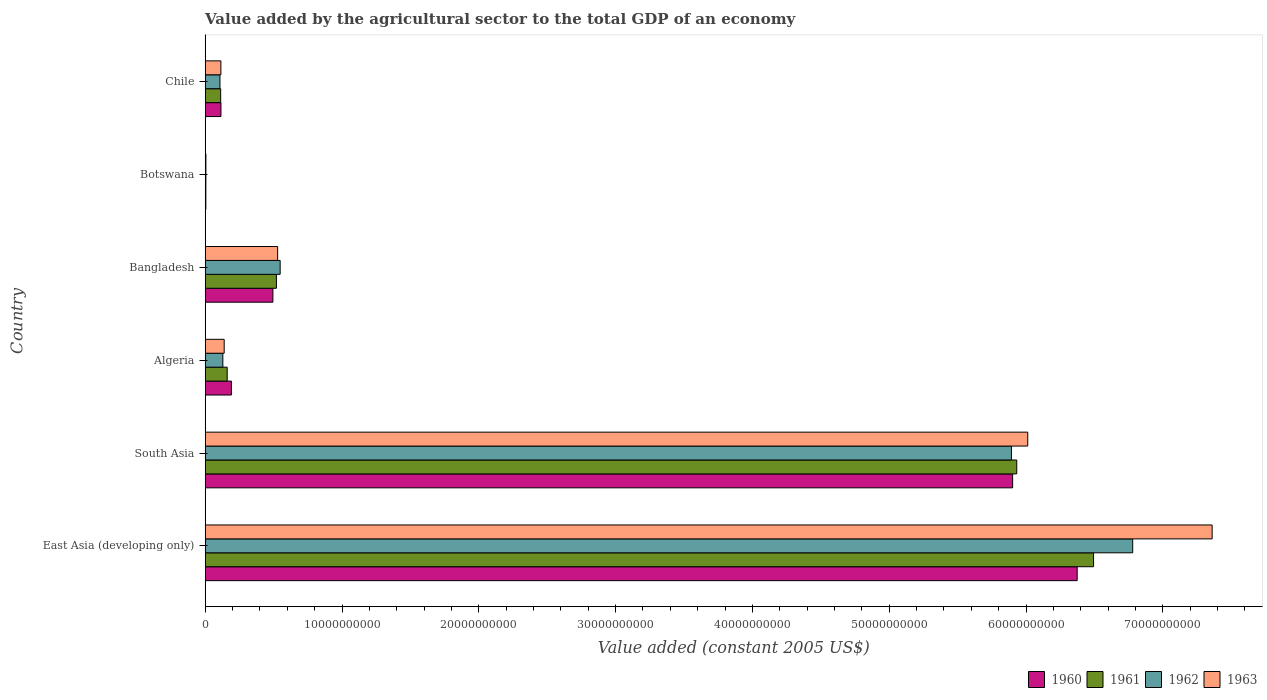How many different coloured bars are there?
Your answer should be very brief. 4. Are the number of bars per tick equal to the number of legend labels?
Offer a very short reply. Yes. How many bars are there on the 6th tick from the top?
Make the answer very short. 4. How many bars are there on the 1st tick from the bottom?
Keep it short and to the point. 4. What is the value added by the agricultural sector in 1962 in Algeria?
Your answer should be compact. 1.29e+09. Across all countries, what is the maximum value added by the agricultural sector in 1963?
Your answer should be very brief. 7.36e+1. Across all countries, what is the minimum value added by the agricultural sector in 1961?
Offer a very short reply. 4.86e+07. In which country was the value added by the agricultural sector in 1960 maximum?
Offer a terse response. East Asia (developing only). In which country was the value added by the agricultural sector in 1963 minimum?
Your answer should be very brief. Botswana. What is the total value added by the agricultural sector in 1961 in the graph?
Your response must be concise. 1.32e+11. What is the difference between the value added by the agricultural sector in 1963 in Chile and that in East Asia (developing only)?
Your answer should be compact. -7.25e+1. What is the difference between the value added by the agricultural sector in 1961 in South Asia and the value added by the agricultural sector in 1962 in Bangladesh?
Make the answer very short. 5.38e+1. What is the average value added by the agricultural sector in 1963 per country?
Ensure brevity in your answer.  2.36e+1. What is the difference between the value added by the agricultural sector in 1960 and value added by the agricultural sector in 1963 in Botswana?
Make the answer very short. -4.67e+06. What is the ratio of the value added by the agricultural sector in 1960 in Bangladesh to that in Chile?
Ensure brevity in your answer.  4.3. What is the difference between the highest and the second highest value added by the agricultural sector in 1960?
Your answer should be compact. 4.72e+09. What is the difference between the highest and the lowest value added by the agricultural sector in 1962?
Make the answer very short. 6.77e+1. In how many countries, is the value added by the agricultural sector in 1963 greater than the average value added by the agricultural sector in 1963 taken over all countries?
Provide a short and direct response. 2. Is the sum of the value added by the agricultural sector in 1961 in Algeria and Bangladesh greater than the maximum value added by the agricultural sector in 1962 across all countries?
Make the answer very short. No. Is it the case that in every country, the sum of the value added by the agricultural sector in 1961 and value added by the agricultural sector in 1960 is greater than the sum of value added by the agricultural sector in 1963 and value added by the agricultural sector in 1962?
Provide a succinct answer. No. What does the 1st bar from the bottom in Botswana represents?
Ensure brevity in your answer.  1960. Is it the case that in every country, the sum of the value added by the agricultural sector in 1960 and value added by the agricultural sector in 1961 is greater than the value added by the agricultural sector in 1963?
Provide a succinct answer. Yes. How many legend labels are there?
Make the answer very short. 4. What is the title of the graph?
Keep it short and to the point. Value added by the agricultural sector to the total GDP of an economy. Does "1961" appear as one of the legend labels in the graph?
Ensure brevity in your answer.  Yes. What is the label or title of the X-axis?
Give a very brief answer. Value added (constant 2005 US$). What is the Value added (constant 2005 US$) of 1960 in East Asia (developing only)?
Offer a very short reply. 6.37e+1. What is the Value added (constant 2005 US$) in 1961 in East Asia (developing only)?
Make the answer very short. 6.49e+1. What is the Value added (constant 2005 US$) of 1962 in East Asia (developing only)?
Provide a succinct answer. 6.78e+1. What is the Value added (constant 2005 US$) of 1963 in East Asia (developing only)?
Your answer should be very brief. 7.36e+1. What is the Value added (constant 2005 US$) of 1960 in South Asia?
Offer a very short reply. 5.90e+1. What is the Value added (constant 2005 US$) in 1961 in South Asia?
Your answer should be very brief. 5.93e+1. What is the Value added (constant 2005 US$) of 1962 in South Asia?
Your response must be concise. 5.89e+1. What is the Value added (constant 2005 US$) of 1963 in South Asia?
Ensure brevity in your answer.  6.01e+1. What is the Value added (constant 2005 US$) in 1960 in Algeria?
Your answer should be very brief. 1.92e+09. What is the Value added (constant 2005 US$) of 1961 in Algeria?
Make the answer very short. 1.61e+09. What is the Value added (constant 2005 US$) in 1962 in Algeria?
Make the answer very short. 1.29e+09. What is the Value added (constant 2005 US$) of 1963 in Algeria?
Provide a succinct answer. 1.39e+09. What is the Value added (constant 2005 US$) in 1960 in Bangladesh?
Provide a succinct answer. 4.95e+09. What is the Value added (constant 2005 US$) of 1961 in Bangladesh?
Your answer should be compact. 5.21e+09. What is the Value added (constant 2005 US$) of 1962 in Bangladesh?
Provide a succinct answer. 5.48e+09. What is the Value added (constant 2005 US$) in 1963 in Bangladesh?
Your response must be concise. 5.30e+09. What is the Value added (constant 2005 US$) of 1960 in Botswana?
Provide a short and direct response. 4.74e+07. What is the Value added (constant 2005 US$) of 1961 in Botswana?
Provide a short and direct response. 4.86e+07. What is the Value added (constant 2005 US$) of 1962 in Botswana?
Your answer should be compact. 5.04e+07. What is the Value added (constant 2005 US$) of 1963 in Botswana?
Offer a terse response. 5.21e+07. What is the Value added (constant 2005 US$) of 1960 in Chile?
Give a very brief answer. 1.15e+09. What is the Value added (constant 2005 US$) of 1961 in Chile?
Give a very brief answer. 1.13e+09. What is the Value added (constant 2005 US$) of 1962 in Chile?
Offer a terse response. 1.08e+09. What is the Value added (constant 2005 US$) in 1963 in Chile?
Make the answer very short. 1.15e+09. Across all countries, what is the maximum Value added (constant 2005 US$) of 1960?
Ensure brevity in your answer.  6.37e+1. Across all countries, what is the maximum Value added (constant 2005 US$) of 1961?
Provide a succinct answer. 6.49e+1. Across all countries, what is the maximum Value added (constant 2005 US$) of 1962?
Your response must be concise. 6.78e+1. Across all countries, what is the maximum Value added (constant 2005 US$) in 1963?
Offer a terse response. 7.36e+1. Across all countries, what is the minimum Value added (constant 2005 US$) in 1960?
Your answer should be very brief. 4.74e+07. Across all countries, what is the minimum Value added (constant 2005 US$) in 1961?
Keep it short and to the point. 4.86e+07. Across all countries, what is the minimum Value added (constant 2005 US$) of 1962?
Your response must be concise. 5.04e+07. Across all countries, what is the minimum Value added (constant 2005 US$) of 1963?
Your response must be concise. 5.21e+07. What is the total Value added (constant 2005 US$) of 1960 in the graph?
Make the answer very short. 1.31e+11. What is the total Value added (constant 2005 US$) in 1961 in the graph?
Make the answer very short. 1.32e+11. What is the total Value added (constant 2005 US$) of 1962 in the graph?
Ensure brevity in your answer.  1.35e+11. What is the total Value added (constant 2005 US$) in 1963 in the graph?
Your answer should be compact. 1.42e+11. What is the difference between the Value added (constant 2005 US$) in 1960 in East Asia (developing only) and that in South Asia?
Give a very brief answer. 4.72e+09. What is the difference between the Value added (constant 2005 US$) of 1961 in East Asia (developing only) and that in South Asia?
Give a very brief answer. 5.62e+09. What is the difference between the Value added (constant 2005 US$) in 1962 in East Asia (developing only) and that in South Asia?
Your response must be concise. 8.86e+09. What is the difference between the Value added (constant 2005 US$) of 1963 in East Asia (developing only) and that in South Asia?
Provide a short and direct response. 1.35e+1. What is the difference between the Value added (constant 2005 US$) of 1960 in East Asia (developing only) and that in Algeria?
Offer a terse response. 6.18e+1. What is the difference between the Value added (constant 2005 US$) of 1961 in East Asia (developing only) and that in Algeria?
Give a very brief answer. 6.33e+1. What is the difference between the Value added (constant 2005 US$) of 1962 in East Asia (developing only) and that in Algeria?
Give a very brief answer. 6.65e+1. What is the difference between the Value added (constant 2005 US$) in 1963 in East Asia (developing only) and that in Algeria?
Make the answer very short. 7.22e+1. What is the difference between the Value added (constant 2005 US$) of 1960 in East Asia (developing only) and that in Bangladesh?
Your answer should be compact. 5.88e+1. What is the difference between the Value added (constant 2005 US$) in 1961 in East Asia (developing only) and that in Bangladesh?
Your answer should be very brief. 5.97e+1. What is the difference between the Value added (constant 2005 US$) in 1962 in East Asia (developing only) and that in Bangladesh?
Provide a short and direct response. 6.23e+1. What is the difference between the Value added (constant 2005 US$) of 1963 in East Asia (developing only) and that in Bangladesh?
Your response must be concise. 6.83e+1. What is the difference between the Value added (constant 2005 US$) of 1960 in East Asia (developing only) and that in Botswana?
Provide a succinct answer. 6.37e+1. What is the difference between the Value added (constant 2005 US$) in 1961 in East Asia (developing only) and that in Botswana?
Make the answer very short. 6.49e+1. What is the difference between the Value added (constant 2005 US$) in 1962 in East Asia (developing only) and that in Botswana?
Your answer should be very brief. 6.77e+1. What is the difference between the Value added (constant 2005 US$) of 1963 in East Asia (developing only) and that in Botswana?
Give a very brief answer. 7.36e+1. What is the difference between the Value added (constant 2005 US$) in 1960 in East Asia (developing only) and that in Chile?
Your response must be concise. 6.26e+1. What is the difference between the Value added (constant 2005 US$) of 1961 in East Asia (developing only) and that in Chile?
Make the answer very short. 6.38e+1. What is the difference between the Value added (constant 2005 US$) in 1962 in East Asia (developing only) and that in Chile?
Give a very brief answer. 6.67e+1. What is the difference between the Value added (constant 2005 US$) of 1963 in East Asia (developing only) and that in Chile?
Ensure brevity in your answer.  7.25e+1. What is the difference between the Value added (constant 2005 US$) in 1960 in South Asia and that in Algeria?
Ensure brevity in your answer.  5.71e+1. What is the difference between the Value added (constant 2005 US$) in 1961 in South Asia and that in Algeria?
Offer a terse response. 5.77e+1. What is the difference between the Value added (constant 2005 US$) in 1962 in South Asia and that in Algeria?
Give a very brief answer. 5.76e+1. What is the difference between the Value added (constant 2005 US$) in 1963 in South Asia and that in Algeria?
Give a very brief answer. 5.87e+1. What is the difference between the Value added (constant 2005 US$) of 1960 in South Asia and that in Bangladesh?
Provide a succinct answer. 5.41e+1. What is the difference between the Value added (constant 2005 US$) in 1961 in South Asia and that in Bangladesh?
Your answer should be very brief. 5.41e+1. What is the difference between the Value added (constant 2005 US$) in 1962 in South Asia and that in Bangladesh?
Provide a succinct answer. 5.35e+1. What is the difference between the Value added (constant 2005 US$) in 1963 in South Asia and that in Bangladesh?
Make the answer very short. 5.48e+1. What is the difference between the Value added (constant 2005 US$) of 1960 in South Asia and that in Botswana?
Provide a short and direct response. 5.90e+1. What is the difference between the Value added (constant 2005 US$) in 1961 in South Asia and that in Botswana?
Your response must be concise. 5.93e+1. What is the difference between the Value added (constant 2005 US$) in 1962 in South Asia and that in Botswana?
Keep it short and to the point. 5.89e+1. What is the difference between the Value added (constant 2005 US$) in 1963 in South Asia and that in Botswana?
Keep it short and to the point. 6.01e+1. What is the difference between the Value added (constant 2005 US$) of 1960 in South Asia and that in Chile?
Provide a succinct answer. 5.79e+1. What is the difference between the Value added (constant 2005 US$) of 1961 in South Asia and that in Chile?
Keep it short and to the point. 5.82e+1. What is the difference between the Value added (constant 2005 US$) of 1962 in South Asia and that in Chile?
Keep it short and to the point. 5.79e+1. What is the difference between the Value added (constant 2005 US$) in 1963 in South Asia and that in Chile?
Give a very brief answer. 5.90e+1. What is the difference between the Value added (constant 2005 US$) of 1960 in Algeria and that in Bangladesh?
Give a very brief answer. -3.03e+09. What is the difference between the Value added (constant 2005 US$) of 1961 in Algeria and that in Bangladesh?
Your answer should be compact. -3.60e+09. What is the difference between the Value added (constant 2005 US$) in 1962 in Algeria and that in Bangladesh?
Keep it short and to the point. -4.19e+09. What is the difference between the Value added (constant 2005 US$) in 1963 in Algeria and that in Bangladesh?
Provide a succinct answer. -3.91e+09. What is the difference between the Value added (constant 2005 US$) of 1960 in Algeria and that in Botswana?
Ensure brevity in your answer.  1.87e+09. What is the difference between the Value added (constant 2005 US$) of 1961 in Algeria and that in Botswana?
Provide a succinct answer. 1.56e+09. What is the difference between the Value added (constant 2005 US$) in 1962 in Algeria and that in Botswana?
Offer a terse response. 1.24e+09. What is the difference between the Value added (constant 2005 US$) in 1963 in Algeria and that in Botswana?
Make the answer very short. 1.34e+09. What is the difference between the Value added (constant 2005 US$) in 1960 in Algeria and that in Chile?
Your response must be concise. 7.63e+08. What is the difference between the Value added (constant 2005 US$) in 1961 in Algeria and that in Chile?
Make the answer very short. 4.78e+08. What is the difference between the Value added (constant 2005 US$) of 1962 in Algeria and that in Chile?
Offer a very short reply. 2.11e+08. What is the difference between the Value added (constant 2005 US$) in 1963 in Algeria and that in Chile?
Offer a terse response. 2.42e+08. What is the difference between the Value added (constant 2005 US$) in 1960 in Bangladesh and that in Botswana?
Ensure brevity in your answer.  4.90e+09. What is the difference between the Value added (constant 2005 US$) of 1961 in Bangladesh and that in Botswana?
Provide a short and direct response. 5.16e+09. What is the difference between the Value added (constant 2005 US$) in 1962 in Bangladesh and that in Botswana?
Offer a terse response. 5.43e+09. What is the difference between the Value added (constant 2005 US$) in 1963 in Bangladesh and that in Botswana?
Offer a very short reply. 5.24e+09. What is the difference between the Value added (constant 2005 US$) in 1960 in Bangladesh and that in Chile?
Ensure brevity in your answer.  3.80e+09. What is the difference between the Value added (constant 2005 US$) in 1961 in Bangladesh and that in Chile?
Make the answer very short. 4.08e+09. What is the difference between the Value added (constant 2005 US$) of 1962 in Bangladesh and that in Chile?
Your response must be concise. 4.40e+09. What is the difference between the Value added (constant 2005 US$) in 1963 in Bangladesh and that in Chile?
Keep it short and to the point. 4.15e+09. What is the difference between the Value added (constant 2005 US$) in 1960 in Botswana and that in Chile?
Offer a very short reply. -1.10e+09. What is the difference between the Value added (constant 2005 US$) of 1961 in Botswana and that in Chile?
Provide a succinct answer. -1.08e+09. What is the difference between the Value added (constant 2005 US$) of 1962 in Botswana and that in Chile?
Your response must be concise. -1.03e+09. What is the difference between the Value added (constant 2005 US$) in 1963 in Botswana and that in Chile?
Offer a very short reply. -1.09e+09. What is the difference between the Value added (constant 2005 US$) in 1960 in East Asia (developing only) and the Value added (constant 2005 US$) in 1961 in South Asia?
Keep it short and to the point. 4.42e+09. What is the difference between the Value added (constant 2005 US$) in 1960 in East Asia (developing only) and the Value added (constant 2005 US$) in 1962 in South Asia?
Keep it short and to the point. 4.81e+09. What is the difference between the Value added (constant 2005 US$) in 1960 in East Asia (developing only) and the Value added (constant 2005 US$) in 1963 in South Asia?
Make the answer very short. 3.61e+09. What is the difference between the Value added (constant 2005 US$) in 1961 in East Asia (developing only) and the Value added (constant 2005 US$) in 1962 in South Asia?
Provide a short and direct response. 6.00e+09. What is the difference between the Value added (constant 2005 US$) of 1961 in East Asia (developing only) and the Value added (constant 2005 US$) of 1963 in South Asia?
Provide a short and direct response. 4.81e+09. What is the difference between the Value added (constant 2005 US$) of 1962 in East Asia (developing only) and the Value added (constant 2005 US$) of 1963 in South Asia?
Ensure brevity in your answer.  7.67e+09. What is the difference between the Value added (constant 2005 US$) of 1960 in East Asia (developing only) and the Value added (constant 2005 US$) of 1961 in Algeria?
Offer a very short reply. 6.21e+1. What is the difference between the Value added (constant 2005 US$) of 1960 in East Asia (developing only) and the Value added (constant 2005 US$) of 1962 in Algeria?
Your response must be concise. 6.24e+1. What is the difference between the Value added (constant 2005 US$) in 1960 in East Asia (developing only) and the Value added (constant 2005 US$) in 1963 in Algeria?
Offer a very short reply. 6.23e+1. What is the difference between the Value added (constant 2005 US$) in 1961 in East Asia (developing only) and the Value added (constant 2005 US$) in 1962 in Algeria?
Keep it short and to the point. 6.36e+1. What is the difference between the Value added (constant 2005 US$) in 1961 in East Asia (developing only) and the Value added (constant 2005 US$) in 1963 in Algeria?
Offer a very short reply. 6.35e+1. What is the difference between the Value added (constant 2005 US$) in 1962 in East Asia (developing only) and the Value added (constant 2005 US$) in 1963 in Algeria?
Your answer should be compact. 6.64e+1. What is the difference between the Value added (constant 2005 US$) in 1960 in East Asia (developing only) and the Value added (constant 2005 US$) in 1961 in Bangladesh?
Your answer should be compact. 5.85e+1. What is the difference between the Value added (constant 2005 US$) in 1960 in East Asia (developing only) and the Value added (constant 2005 US$) in 1962 in Bangladesh?
Keep it short and to the point. 5.83e+1. What is the difference between the Value added (constant 2005 US$) in 1960 in East Asia (developing only) and the Value added (constant 2005 US$) in 1963 in Bangladesh?
Provide a short and direct response. 5.84e+1. What is the difference between the Value added (constant 2005 US$) in 1961 in East Asia (developing only) and the Value added (constant 2005 US$) in 1962 in Bangladesh?
Make the answer very short. 5.95e+1. What is the difference between the Value added (constant 2005 US$) of 1961 in East Asia (developing only) and the Value added (constant 2005 US$) of 1963 in Bangladesh?
Offer a terse response. 5.96e+1. What is the difference between the Value added (constant 2005 US$) in 1962 in East Asia (developing only) and the Value added (constant 2005 US$) in 1963 in Bangladesh?
Your answer should be compact. 6.25e+1. What is the difference between the Value added (constant 2005 US$) in 1960 in East Asia (developing only) and the Value added (constant 2005 US$) in 1961 in Botswana?
Your answer should be compact. 6.37e+1. What is the difference between the Value added (constant 2005 US$) in 1960 in East Asia (developing only) and the Value added (constant 2005 US$) in 1962 in Botswana?
Ensure brevity in your answer.  6.37e+1. What is the difference between the Value added (constant 2005 US$) in 1960 in East Asia (developing only) and the Value added (constant 2005 US$) in 1963 in Botswana?
Provide a succinct answer. 6.37e+1. What is the difference between the Value added (constant 2005 US$) in 1961 in East Asia (developing only) and the Value added (constant 2005 US$) in 1962 in Botswana?
Ensure brevity in your answer.  6.49e+1. What is the difference between the Value added (constant 2005 US$) of 1961 in East Asia (developing only) and the Value added (constant 2005 US$) of 1963 in Botswana?
Keep it short and to the point. 6.49e+1. What is the difference between the Value added (constant 2005 US$) in 1962 in East Asia (developing only) and the Value added (constant 2005 US$) in 1963 in Botswana?
Offer a very short reply. 6.77e+1. What is the difference between the Value added (constant 2005 US$) in 1960 in East Asia (developing only) and the Value added (constant 2005 US$) in 1961 in Chile?
Offer a terse response. 6.26e+1. What is the difference between the Value added (constant 2005 US$) of 1960 in East Asia (developing only) and the Value added (constant 2005 US$) of 1962 in Chile?
Keep it short and to the point. 6.27e+1. What is the difference between the Value added (constant 2005 US$) of 1960 in East Asia (developing only) and the Value added (constant 2005 US$) of 1963 in Chile?
Provide a short and direct response. 6.26e+1. What is the difference between the Value added (constant 2005 US$) of 1961 in East Asia (developing only) and the Value added (constant 2005 US$) of 1962 in Chile?
Your answer should be compact. 6.39e+1. What is the difference between the Value added (constant 2005 US$) of 1961 in East Asia (developing only) and the Value added (constant 2005 US$) of 1963 in Chile?
Keep it short and to the point. 6.38e+1. What is the difference between the Value added (constant 2005 US$) in 1962 in East Asia (developing only) and the Value added (constant 2005 US$) in 1963 in Chile?
Make the answer very short. 6.66e+1. What is the difference between the Value added (constant 2005 US$) in 1960 in South Asia and the Value added (constant 2005 US$) in 1961 in Algeria?
Keep it short and to the point. 5.74e+1. What is the difference between the Value added (constant 2005 US$) of 1960 in South Asia and the Value added (constant 2005 US$) of 1962 in Algeria?
Offer a very short reply. 5.77e+1. What is the difference between the Value added (constant 2005 US$) in 1960 in South Asia and the Value added (constant 2005 US$) in 1963 in Algeria?
Provide a succinct answer. 5.76e+1. What is the difference between the Value added (constant 2005 US$) of 1961 in South Asia and the Value added (constant 2005 US$) of 1962 in Algeria?
Make the answer very short. 5.80e+1. What is the difference between the Value added (constant 2005 US$) of 1961 in South Asia and the Value added (constant 2005 US$) of 1963 in Algeria?
Your answer should be very brief. 5.79e+1. What is the difference between the Value added (constant 2005 US$) of 1962 in South Asia and the Value added (constant 2005 US$) of 1963 in Algeria?
Your answer should be very brief. 5.75e+1. What is the difference between the Value added (constant 2005 US$) in 1960 in South Asia and the Value added (constant 2005 US$) in 1961 in Bangladesh?
Provide a short and direct response. 5.38e+1. What is the difference between the Value added (constant 2005 US$) of 1960 in South Asia and the Value added (constant 2005 US$) of 1962 in Bangladesh?
Ensure brevity in your answer.  5.35e+1. What is the difference between the Value added (constant 2005 US$) of 1960 in South Asia and the Value added (constant 2005 US$) of 1963 in Bangladesh?
Make the answer very short. 5.37e+1. What is the difference between the Value added (constant 2005 US$) of 1961 in South Asia and the Value added (constant 2005 US$) of 1962 in Bangladesh?
Keep it short and to the point. 5.38e+1. What is the difference between the Value added (constant 2005 US$) in 1961 in South Asia and the Value added (constant 2005 US$) in 1963 in Bangladesh?
Provide a succinct answer. 5.40e+1. What is the difference between the Value added (constant 2005 US$) in 1962 in South Asia and the Value added (constant 2005 US$) in 1963 in Bangladesh?
Ensure brevity in your answer.  5.36e+1. What is the difference between the Value added (constant 2005 US$) of 1960 in South Asia and the Value added (constant 2005 US$) of 1961 in Botswana?
Provide a succinct answer. 5.90e+1. What is the difference between the Value added (constant 2005 US$) in 1960 in South Asia and the Value added (constant 2005 US$) in 1962 in Botswana?
Give a very brief answer. 5.90e+1. What is the difference between the Value added (constant 2005 US$) of 1960 in South Asia and the Value added (constant 2005 US$) of 1963 in Botswana?
Keep it short and to the point. 5.90e+1. What is the difference between the Value added (constant 2005 US$) of 1961 in South Asia and the Value added (constant 2005 US$) of 1962 in Botswana?
Provide a short and direct response. 5.93e+1. What is the difference between the Value added (constant 2005 US$) in 1961 in South Asia and the Value added (constant 2005 US$) in 1963 in Botswana?
Give a very brief answer. 5.93e+1. What is the difference between the Value added (constant 2005 US$) in 1962 in South Asia and the Value added (constant 2005 US$) in 1963 in Botswana?
Ensure brevity in your answer.  5.89e+1. What is the difference between the Value added (constant 2005 US$) in 1960 in South Asia and the Value added (constant 2005 US$) in 1961 in Chile?
Your answer should be very brief. 5.79e+1. What is the difference between the Value added (constant 2005 US$) in 1960 in South Asia and the Value added (constant 2005 US$) in 1962 in Chile?
Offer a very short reply. 5.79e+1. What is the difference between the Value added (constant 2005 US$) in 1960 in South Asia and the Value added (constant 2005 US$) in 1963 in Chile?
Your response must be concise. 5.79e+1. What is the difference between the Value added (constant 2005 US$) of 1961 in South Asia and the Value added (constant 2005 US$) of 1962 in Chile?
Your answer should be compact. 5.82e+1. What is the difference between the Value added (constant 2005 US$) of 1961 in South Asia and the Value added (constant 2005 US$) of 1963 in Chile?
Give a very brief answer. 5.82e+1. What is the difference between the Value added (constant 2005 US$) in 1962 in South Asia and the Value added (constant 2005 US$) in 1963 in Chile?
Give a very brief answer. 5.78e+1. What is the difference between the Value added (constant 2005 US$) in 1960 in Algeria and the Value added (constant 2005 US$) in 1961 in Bangladesh?
Offer a terse response. -3.29e+09. What is the difference between the Value added (constant 2005 US$) of 1960 in Algeria and the Value added (constant 2005 US$) of 1962 in Bangladesh?
Provide a succinct answer. -3.56e+09. What is the difference between the Value added (constant 2005 US$) in 1960 in Algeria and the Value added (constant 2005 US$) in 1963 in Bangladesh?
Make the answer very short. -3.38e+09. What is the difference between the Value added (constant 2005 US$) in 1961 in Algeria and the Value added (constant 2005 US$) in 1962 in Bangladesh?
Your response must be concise. -3.87e+09. What is the difference between the Value added (constant 2005 US$) in 1961 in Algeria and the Value added (constant 2005 US$) in 1963 in Bangladesh?
Offer a very short reply. -3.69e+09. What is the difference between the Value added (constant 2005 US$) in 1962 in Algeria and the Value added (constant 2005 US$) in 1963 in Bangladesh?
Your answer should be compact. -4.00e+09. What is the difference between the Value added (constant 2005 US$) in 1960 in Algeria and the Value added (constant 2005 US$) in 1961 in Botswana?
Your answer should be very brief. 1.87e+09. What is the difference between the Value added (constant 2005 US$) in 1960 in Algeria and the Value added (constant 2005 US$) in 1962 in Botswana?
Make the answer very short. 1.86e+09. What is the difference between the Value added (constant 2005 US$) in 1960 in Algeria and the Value added (constant 2005 US$) in 1963 in Botswana?
Give a very brief answer. 1.86e+09. What is the difference between the Value added (constant 2005 US$) of 1961 in Algeria and the Value added (constant 2005 US$) of 1962 in Botswana?
Your response must be concise. 1.56e+09. What is the difference between the Value added (constant 2005 US$) of 1961 in Algeria and the Value added (constant 2005 US$) of 1963 in Botswana?
Your answer should be compact. 1.56e+09. What is the difference between the Value added (constant 2005 US$) of 1962 in Algeria and the Value added (constant 2005 US$) of 1963 in Botswana?
Offer a terse response. 1.24e+09. What is the difference between the Value added (constant 2005 US$) in 1960 in Algeria and the Value added (constant 2005 US$) in 1961 in Chile?
Keep it short and to the point. 7.85e+08. What is the difference between the Value added (constant 2005 US$) of 1960 in Algeria and the Value added (constant 2005 US$) of 1962 in Chile?
Provide a short and direct response. 8.36e+08. What is the difference between the Value added (constant 2005 US$) of 1960 in Algeria and the Value added (constant 2005 US$) of 1963 in Chile?
Offer a very short reply. 7.69e+08. What is the difference between the Value added (constant 2005 US$) of 1961 in Algeria and the Value added (constant 2005 US$) of 1962 in Chile?
Your answer should be very brief. 5.29e+08. What is the difference between the Value added (constant 2005 US$) in 1961 in Algeria and the Value added (constant 2005 US$) in 1963 in Chile?
Make the answer very short. 4.62e+08. What is the difference between the Value added (constant 2005 US$) of 1962 in Algeria and the Value added (constant 2005 US$) of 1963 in Chile?
Offer a very short reply. 1.44e+08. What is the difference between the Value added (constant 2005 US$) in 1960 in Bangladesh and the Value added (constant 2005 US$) in 1961 in Botswana?
Make the answer very short. 4.90e+09. What is the difference between the Value added (constant 2005 US$) in 1960 in Bangladesh and the Value added (constant 2005 US$) in 1962 in Botswana?
Offer a very short reply. 4.90e+09. What is the difference between the Value added (constant 2005 US$) of 1960 in Bangladesh and the Value added (constant 2005 US$) of 1963 in Botswana?
Your response must be concise. 4.90e+09. What is the difference between the Value added (constant 2005 US$) of 1961 in Bangladesh and the Value added (constant 2005 US$) of 1962 in Botswana?
Your response must be concise. 5.16e+09. What is the difference between the Value added (constant 2005 US$) in 1961 in Bangladesh and the Value added (constant 2005 US$) in 1963 in Botswana?
Your answer should be very brief. 5.15e+09. What is the difference between the Value added (constant 2005 US$) of 1962 in Bangladesh and the Value added (constant 2005 US$) of 1963 in Botswana?
Provide a succinct answer. 5.43e+09. What is the difference between the Value added (constant 2005 US$) in 1960 in Bangladesh and the Value added (constant 2005 US$) in 1961 in Chile?
Your answer should be very brief. 3.82e+09. What is the difference between the Value added (constant 2005 US$) in 1960 in Bangladesh and the Value added (constant 2005 US$) in 1962 in Chile?
Make the answer very short. 3.87e+09. What is the difference between the Value added (constant 2005 US$) of 1960 in Bangladesh and the Value added (constant 2005 US$) of 1963 in Chile?
Make the answer very short. 3.80e+09. What is the difference between the Value added (constant 2005 US$) in 1961 in Bangladesh and the Value added (constant 2005 US$) in 1962 in Chile?
Provide a short and direct response. 4.13e+09. What is the difference between the Value added (constant 2005 US$) in 1961 in Bangladesh and the Value added (constant 2005 US$) in 1963 in Chile?
Offer a terse response. 4.06e+09. What is the difference between the Value added (constant 2005 US$) of 1962 in Bangladesh and the Value added (constant 2005 US$) of 1963 in Chile?
Offer a very short reply. 4.33e+09. What is the difference between the Value added (constant 2005 US$) in 1960 in Botswana and the Value added (constant 2005 US$) in 1961 in Chile?
Provide a succinct answer. -1.08e+09. What is the difference between the Value added (constant 2005 US$) in 1960 in Botswana and the Value added (constant 2005 US$) in 1962 in Chile?
Give a very brief answer. -1.03e+09. What is the difference between the Value added (constant 2005 US$) of 1960 in Botswana and the Value added (constant 2005 US$) of 1963 in Chile?
Give a very brief answer. -1.10e+09. What is the difference between the Value added (constant 2005 US$) in 1961 in Botswana and the Value added (constant 2005 US$) in 1962 in Chile?
Your answer should be very brief. -1.03e+09. What is the difference between the Value added (constant 2005 US$) in 1961 in Botswana and the Value added (constant 2005 US$) in 1963 in Chile?
Keep it short and to the point. -1.10e+09. What is the difference between the Value added (constant 2005 US$) of 1962 in Botswana and the Value added (constant 2005 US$) of 1963 in Chile?
Make the answer very short. -1.10e+09. What is the average Value added (constant 2005 US$) in 1960 per country?
Your answer should be very brief. 2.18e+1. What is the average Value added (constant 2005 US$) of 1961 per country?
Provide a short and direct response. 2.20e+1. What is the average Value added (constant 2005 US$) in 1962 per country?
Provide a succinct answer. 2.24e+1. What is the average Value added (constant 2005 US$) of 1963 per country?
Make the answer very short. 2.36e+1. What is the difference between the Value added (constant 2005 US$) in 1960 and Value added (constant 2005 US$) in 1961 in East Asia (developing only)?
Give a very brief answer. -1.20e+09. What is the difference between the Value added (constant 2005 US$) of 1960 and Value added (constant 2005 US$) of 1962 in East Asia (developing only)?
Provide a short and direct response. -4.06e+09. What is the difference between the Value added (constant 2005 US$) in 1960 and Value added (constant 2005 US$) in 1963 in East Asia (developing only)?
Your answer should be compact. -9.86e+09. What is the difference between the Value added (constant 2005 US$) in 1961 and Value added (constant 2005 US$) in 1962 in East Asia (developing only)?
Offer a very short reply. -2.86e+09. What is the difference between the Value added (constant 2005 US$) of 1961 and Value added (constant 2005 US$) of 1963 in East Asia (developing only)?
Ensure brevity in your answer.  -8.67e+09. What is the difference between the Value added (constant 2005 US$) in 1962 and Value added (constant 2005 US$) in 1963 in East Asia (developing only)?
Ensure brevity in your answer.  -5.81e+09. What is the difference between the Value added (constant 2005 US$) in 1960 and Value added (constant 2005 US$) in 1961 in South Asia?
Your answer should be very brief. -3.02e+08. What is the difference between the Value added (constant 2005 US$) of 1960 and Value added (constant 2005 US$) of 1962 in South Asia?
Your response must be concise. 8.71e+07. What is the difference between the Value added (constant 2005 US$) of 1960 and Value added (constant 2005 US$) of 1963 in South Asia?
Ensure brevity in your answer.  -1.11e+09. What is the difference between the Value added (constant 2005 US$) in 1961 and Value added (constant 2005 US$) in 1962 in South Asia?
Give a very brief answer. 3.89e+08. What is the difference between the Value added (constant 2005 US$) of 1961 and Value added (constant 2005 US$) of 1963 in South Asia?
Your answer should be compact. -8.04e+08. What is the difference between the Value added (constant 2005 US$) of 1962 and Value added (constant 2005 US$) of 1963 in South Asia?
Provide a succinct answer. -1.19e+09. What is the difference between the Value added (constant 2005 US$) of 1960 and Value added (constant 2005 US$) of 1961 in Algeria?
Offer a very short reply. 3.07e+08. What is the difference between the Value added (constant 2005 US$) of 1960 and Value added (constant 2005 US$) of 1962 in Algeria?
Your response must be concise. 6.25e+08. What is the difference between the Value added (constant 2005 US$) in 1960 and Value added (constant 2005 US$) in 1963 in Algeria?
Make the answer very short. 5.27e+08. What is the difference between the Value added (constant 2005 US$) of 1961 and Value added (constant 2005 US$) of 1962 in Algeria?
Offer a terse response. 3.18e+08. What is the difference between the Value added (constant 2005 US$) of 1961 and Value added (constant 2005 US$) of 1963 in Algeria?
Offer a terse response. 2.20e+08. What is the difference between the Value added (constant 2005 US$) in 1962 and Value added (constant 2005 US$) in 1963 in Algeria?
Provide a succinct answer. -9.79e+07. What is the difference between the Value added (constant 2005 US$) of 1960 and Value added (constant 2005 US$) of 1961 in Bangladesh?
Your answer should be very brief. -2.58e+08. What is the difference between the Value added (constant 2005 US$) in 1960 and Value added (constant 2005 US$) in 1962 in Bangladesh?
Provide a succinct answer. -5.31e+08. What is the difference between the Value added (constant 2005 US$) of 1960 and Value added (constant 2005 US$) of 1963 in Bangladesh?
Offer a terse response. -3.47e+08. What is the difference between the Value added (constant 2005 US$) in 1961 and Value added (constant 2005 US$) in 1962 in Bangladesh?
Ensure brevity in your answer.  -2.73e+08. What is the difference between the Value added (constant 2005 US$) of 1961 and Value added (constant 2005 US$) of 1963 in Bangladesh?
Offer a terse response. -8.88e+07. What is the difference between the Value added (constant 2005 US$) of 1962 and Value added (constant 2005 US$) of 1963 in Bangladesh?
Provide a succinct answer. 1.84e+08. What is the difference between the Value added (constant 2005 US$) of 1960 and Value added (constant 2005 US$) of 1961 in Botswana?
Make the answer very short. -1.17e+06. What is the difference between the Value added (constant 2005 US$) of 1960 and Value added (constant 2005 US$) of 1962 in Botswana?
Make the answer very short. -2.92e+06. What is the difference between the Value added (constant 2005 US$) of 1960 and Value added (constant 2005 US$) of 1963 in Botswana?
Your answer should be very brief. -4.67e+06. What is the difference between the Value added (constant 2005 US$) in 1961 and Value added (constant 2005 US$) in 1962 in Botswana?
Keep it short and to the point. -1.75e+06. What is the difference between the Value added (constant 2005 US$) of 1961 and Value added (constant 2005 US$) of 1963 in Botswana?
Provide a succinct answer. -3.51e+06. What is the difference between the Value added (constant 2005 US$) in 1962 and Value added (constant 2005 US$) in 1963 in Botswana?
Keep it short and to the point. -1.75e+06. What is the difference between the Value added (constant 2005 US$) in 1960 and Value added (constant 2005 US$) in 1961 in Chile?
Your answer should be very brief. 2.12e+07. What is the difference between the Value added (constant 2005 US$) of 1960 and Value added (constant 2005 US$) of 1962 in Chile?
Your response must be concise. 7.27e+07. What is the difference between the Value added (constant 2005 US$) of 1960 and Value added (constant 2005 US$) of 1963 in Chile?
Provide a short and direct response. 5.74e+06. What is the difference between the Value added (constant 2005 US$) of 1961 and Value added (constant 2005 US$) of 1962 in Chile?
Make the answer very short. 5.15e+07. What is the difference between the Value added (constant 2005 US$) in 1961 and Value added (constant 2005 US$) in 1963 in Chile?
Offer a very short reply. -1.54e+07. What is the difference between the Value added (constant 2005 US$) of 1962 and Value added (constant 2005 US$) of 1963 in Chile?
Your answer should be very brief. -6.69e+07. What is the ratio of the Value added (constant 2005 US$) of 1960 in East Asia (developing only) to that in South Asia?
Make the answer very short. 1.08. What is the ratio of the Value added (constant 2005 US$) of 1961 in East Asia (developing only) to that in South Asia?
Your answer should be very brief. 1.09. What is the ratio of the Value added (constant 2005 US$) of 1962 in East Asia (developing only) to that in South Asia?
Ensure brevity in your answer.  1.15. What is the ratio of the Value added (constant 2005 US$) in 1963 in East Asia (developing only) to that in South Asia?
Keep it short and to the point. 1.22. What is the ratio of the Value added (constant 2005 US$) of 1960 in East Asia (developing only) to that in Algeria?
Your response must be concise. 33.28. What is the ratio of the Value added (constant 2005 US$) of 1961 in East Asia (developing only) to that in Algeria?
Your answer should be compact. 40.37. What is the ratio of the Value added (constant 2005 US$) of 1962 in East Asia (developing only) to that in Algeria?
Ensure brevity in your answer.  52.55. What is the ratio of the Value added (constant 2005 US$) in 1963 in East Asia (developing only) to that in Algeria?
Keep it short and to the point. 53.02. What is the ratio of the Value added (constant 2005 US$) in 1960 in East Asia (developing only) to that in Bangladesh?
Keep it short and to the point. 12.88. What is the ratio of the Value added (constant 2005 US$) of 1961 in East Asia (developing only) to that in Bangladesh?
Offer a very short reply. 12.47. What is the ratio of the Value added (constant 2005 US$) of 1962 in East Asia (developing only) to that in Bangladesh?
Provide a succinct answer. 12.37. What is the ratio of the Value added (constant 2005 US$) of 1963 in East Asia (developing only) to that in Bangladesh?
Provide a succinct answer. 13.9. What is the ratio of the Value added (constant 2005 US$) in 1960 in East Asia (developing only) to that in Botswana?
Ensure brevity in your answer.  1343.36. What is the ratio of the Value added (constant 2005 US$) of 1961 in East Asia (developing only) to that in Botswana?
Offer a terse response. 1335.7. What is the ratio of the Value added (constant 2005 US$) in 1962 in East Asia (developing only) to that in Botswana?
Ensure brevity in your answer.  1345.99. What is the ratio of the Value added (constant 2005 US$) in 1963 in East Asia (developing only) to that in Botswana?
Your response must be concise. 1412.14. What is the ratio of the Value added (constant 2005 US$) in 1960 in East Asia (developing only) to that in Chile?
Your answer should be very brief. 55.33. What is the ratio of the Value added (constant 2005 US$) in 1961 in East Asia (developing only) to that in Chile?
Make the answer very short. 57.43. What is the ratio of the Value added (constant 2005 US$) in 1962 in East Asia (developing only) to that in Chile?
Make the answer very short. 62.82. What is the ratio of the Value added (constant 2005 US$) in 1963 in East Asia (developing only) to that in Chile?
Your answer should be very brief. 64.22. What is the ratio of the Value added (constant 2005 US$) of 1960 in South Asia to that in Algeria?
Your answer should be very brief. 30.81. What is the ratio of the Value added (constant 2005 US$) in 1961 in South Asia to that in Algeria?
Give a very brief answer. 36.88. What is the ratio of the Value added (constant 2005 US$) in 1962 in South Asia to that in Algeria?
Your answer should be compact. 45.68. What is the ratio of the Value added (constant 2005 US$) of 1963 in South Asia to that in Algeria?
Ensure brevity in your answer.  43.31. What is the ratio of the Value added (constant 2005 US$) of 1960 in South Asia to that in Bangladesh?
Ensure brevity in your answer.  11.93. What is the ratio of the Value added (constant 2005 US$) in 1961 in South Asia to that in Bangladesh?
Provide a short and direct response. 11.39. What is the ratio of the Value added (constant 2005 US$) of 1962 in South Asia to that in Bangladesh?
Keep it short and to the point. 10.75. What is the ratio of the Value added (constant 2005 US$) of 1963 in South Asia to that in Bangladesh?
Your answer should be compact. 11.35. What is the ratio of the Value added (constant 2005 US$) of 1960 in South Asia to that in Botswana?
Keep it short and to the point. 1243.88. What is the ratio of the Value added (constant 2005 US$) in 1961 in South Asia to that in Botswana?
Your answer should be compact. 1220.19. What is the ratio of the Value added (constant 2005 US$) in 1962 in South Asia to that in Botswana?
Provide a succinct answer. 1170. What is the ratio of the Value added (constant 2005 US$) of 1963 in South Asia to that in Botswana?
Your response must be concise. 1153.54. What is the ratio of the Value added (constant 2005 US$) of 1960 in South Asia to that in Chile?
Provide a succinct answer. 51.24. What is the ratio of the Value added (constant 2005 US$) of 1961 in South Asia to that in Chile?
Your answer should be compact. 52.46. What is the ratio of the Value added (constant 2005 US$) in 1962 in South Asia to that in Chile?
Offer a very short reply. 54.61. What is the ratio of the Value added (constant 2005 US$) in 1963 in South Asia to that in Chile?
Provide a succinct answer. 52.46. What is the ratio of the Value added (constant 2005 US$) in 1960 in Algeria to that in Bangladesh?
Offer a terse response. 0.39. What is the ratio of the Value added (constant 2005 US$) of 1961 in Algeria to that in Bangladesh?
Offer a very short reply. 0.31. What is the ratio of the Value added (constant 2005 US$) in 1962 in Algeria to that in Bangladesh?
Keep it short and to the point. 0.24. What is the ratio of the Value added (constant 2005 US$) of 1963 in Algeria to that in Bangladesh?
Your answer should be very brief. 0.26. What is the ratio of the Value added (constant 2005 US$) of 1960 in Algeria to that in Botswana?
Your answer should be very brief. 40.37. What is the ratio of the Value added (constant 2005 US$) of 1961 in Algeria to that in Botswana?
Offer a very short reply. 33.08. What is the ratio of the Value added (constant 2005 US$) in 1962 in Algeria to that in Botswana?
Offer a terse response. 25.62. What is the ratio of the Value added (constant 2005 US$) in 1963 in Algeria to that in Botswana?
Provide a short and direct response. 26.63. What is the ratio of the Value added (constant 2005 US$) of 1960 in Algeria to that in Chile?
Your answer should be very brief. 1.66. What is the ratio of the Value added (constant 2005 US$) in 1961 in Algeria to that in Chile?
Ensure brevity in your answer.  1.42. What is the ratio of the Value added (constant 2005 US$) of 1962 in Algeria to that in Chile?
Your answer should be very brief. 1.2. What is the ratio of the Value added (constant 2005 US$) in 1963 in Algeria to that in Chile?
Provide a short and direct response. 1.21. What is the ratio of the Value added (constant 2005 US$) in 1960 in Bangladesh to that in Botswana?
Offer a terse response. 104.3. What is the ratio of the Value added (constant 2005 US$) in 1961 in Bangladesh to that in Botswana?
Offer a very short reply. 107.09. What is the ratio of the Value added (constant 2005 US$) of 1962 in Bangladesh to that in Botswana?
Keep it short and to the point. 108.79. What is the ratio of the Value added (constant 2005 US$) in 1963 in Bangladesh to that in Botswana?
Offer a terse response. 101.59. What is the ratio of the Value added (constant 2005 US$) of 1960 in Bangladesh to that in Chile?
Provide a succinct answer. 4.3. What is the ratio of the Value added (constant 2005 US$) in 1961 in Bangladesh to that in Chile?
Your answer should be very brief. 4.6. What is the ratio of the Value added (constant 2005 US$) of 1962 in Bangladesh to that in Chile?
Give a very brief answer. 5.08. What is the ratio of the Value added (constant 2005 US$) in 1963 in Bangladesh to that in Chile?
Your answer should be compact. 4.62. What is the ratio of the Value added (constant 2005 US$) of 1960 in Botswana to that in Chile?
Your answer should be very brief. 0.04. What is the ratio of the Value added (constant 2005 US$) in 1961 in Botswana to that in Chile?
Offer a terse response. 0.04. What is the ratio of the Value added (constant 2005 US$) of 1962 in Botswana to that in Chile?
Your response must be concise. 0.05. What is the ratio of the Value added (constant 2005 US$) in 1963 in Botswana to that in Chile?
Your answer should be compact. 0.05. What is the difference between the highest and the second highest Value added (constant 2005 US$) in 1960?
Ensure brevity in your answer.  4.72e+09. What is the difference between the highest and the second highest Value added (constant 2005 US$) of 1961?
Provide a short and direct response. 5.62e+09. What is the difference between the highest and the second highest Value added (constant 2005 US$) of 1962?
Keep it short and to the point. 8.86e+09. What is the difference between the highest and the second highest Value added (constant 2005 US$) in 1963?
Your answer should be compact. 1.35e+1. What is the difference between the highest and the lowest Value added (constant 2005 US$) of 1960?
Ensure brevity in your answer.  6.37e+1. What is the difference between the highest and the lowest Value added (constant 2005 US$) in 1961?
Provide a short and direct response. 6.49e+1. What is the difference between the highest and the lowest Value added (constant 2005 US$) in 1962?
Give a very brief answer. 6.77e+1. What is the difference between the highest and the lowest Value added (constant 2005 US$) in 1963?
Provide a short and direct response. 7.36e+1. 